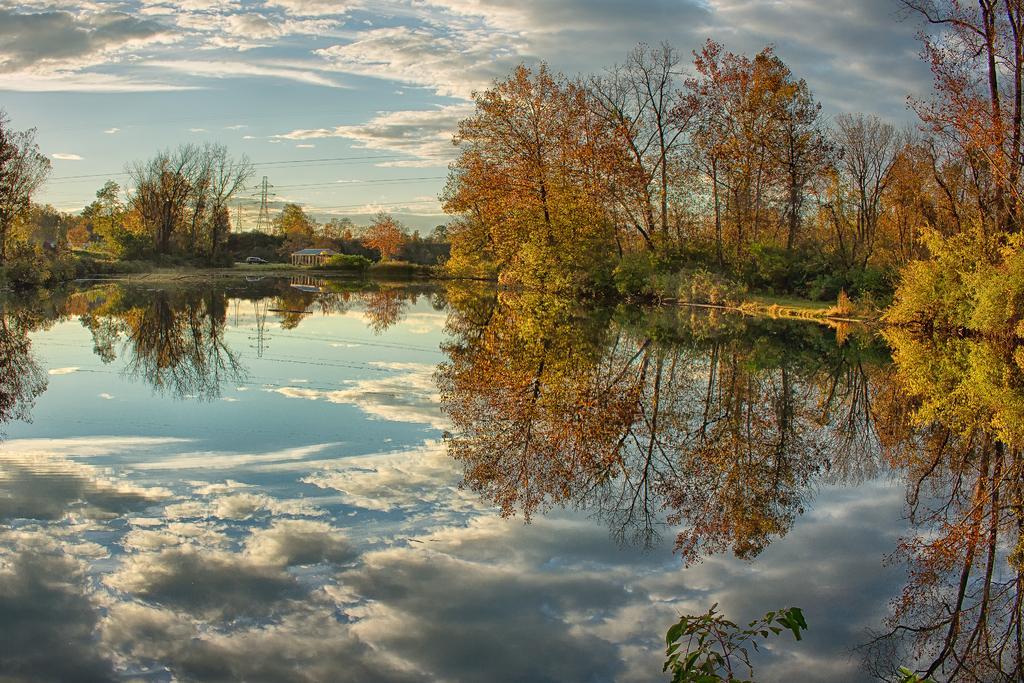Describe this image in one or two sentences. In this image there is a lake and we can see trees. There is a tower and there are wires. In the background there is sky. 